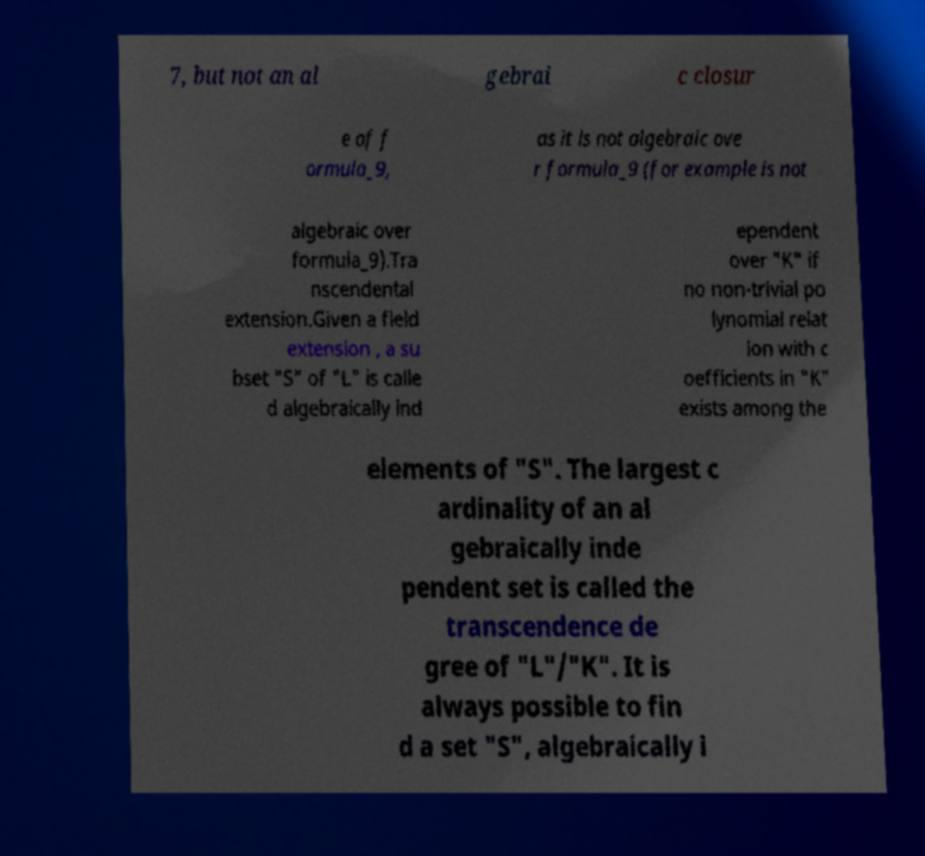There's text embedded in this image that I need extracted. Can you transcribe it verbatim? 7, but not an al gebrai c closur e of f ormula_9, as it is not algebraic ove r formula_9 (for example is not algebraic over formula_9).Tra nscendental extension.Given a field extension , a su bset "S" of "L" is calle d algebraically ind ependent over "K" if no non-trivial po lynomial relat ion with c oefficients in "K" exists among the elements of "S". The largest c ardinality of an al gebraically inde pendent set is called the transcendence de gree of "L"/"K". It is always possible to fin d a set "S", algebraically i 